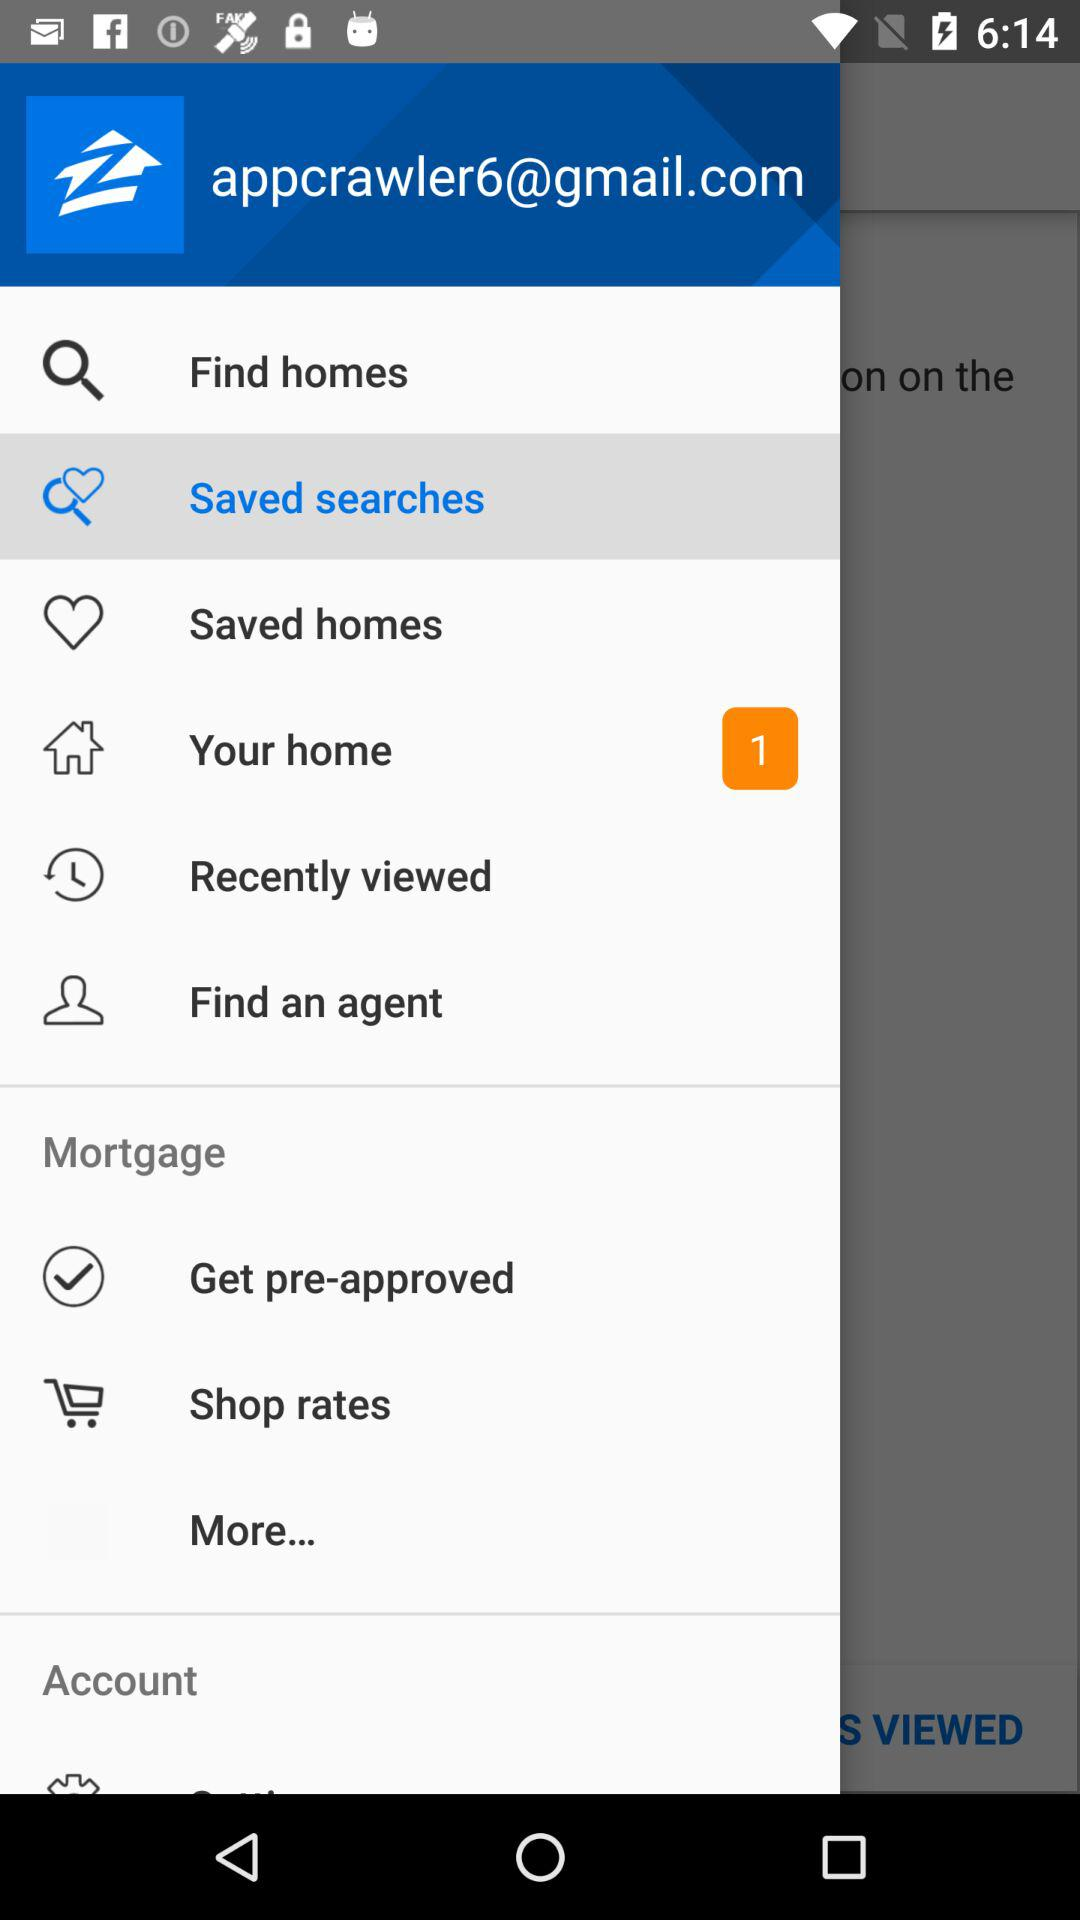What is the email address? The email address is appcrawler6@gmail.com. 